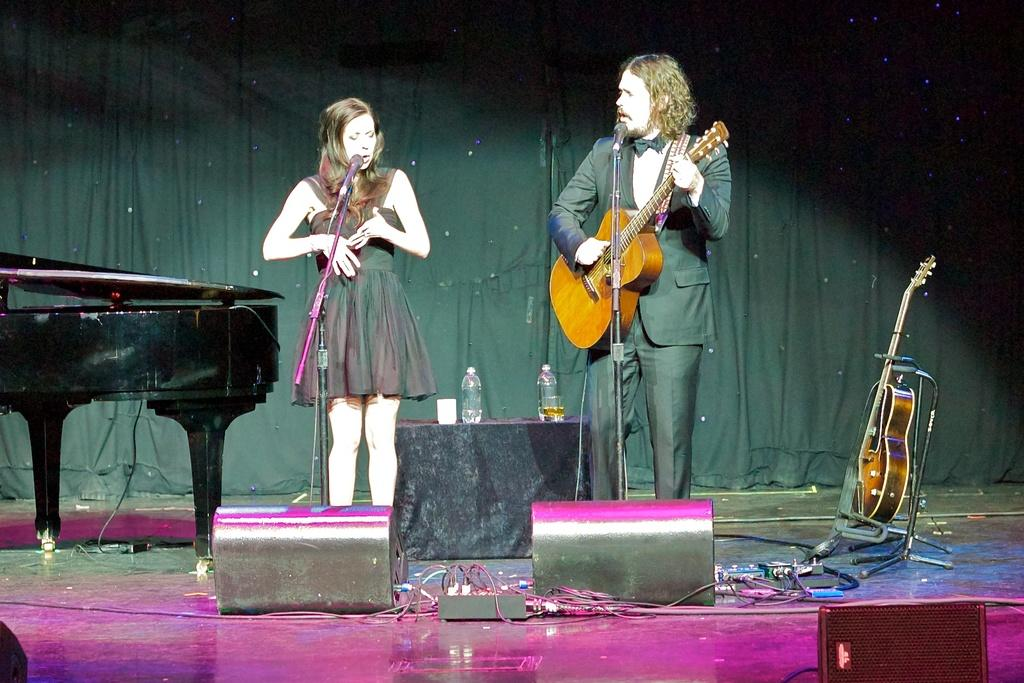What is the woman doing on the stage in the image? The woman is singing on a stage. What is the man doing on the stage in the image? The man is playing guitar on a stage. What musical instruments can be seen in the background of the image? There is a piano and a guitar in the background. What equipment is present for amplification and vocal support in the image? There is a microphone in the background. What items can be seen for hydration and refreshment in the image? There are water bottles and a glass in the background. What type of material is present in the background of the image? There is a cloth in the background. How old is the woman's daughter in the image? There is no mention of a daughter in the image, so we cannot determine her age. 